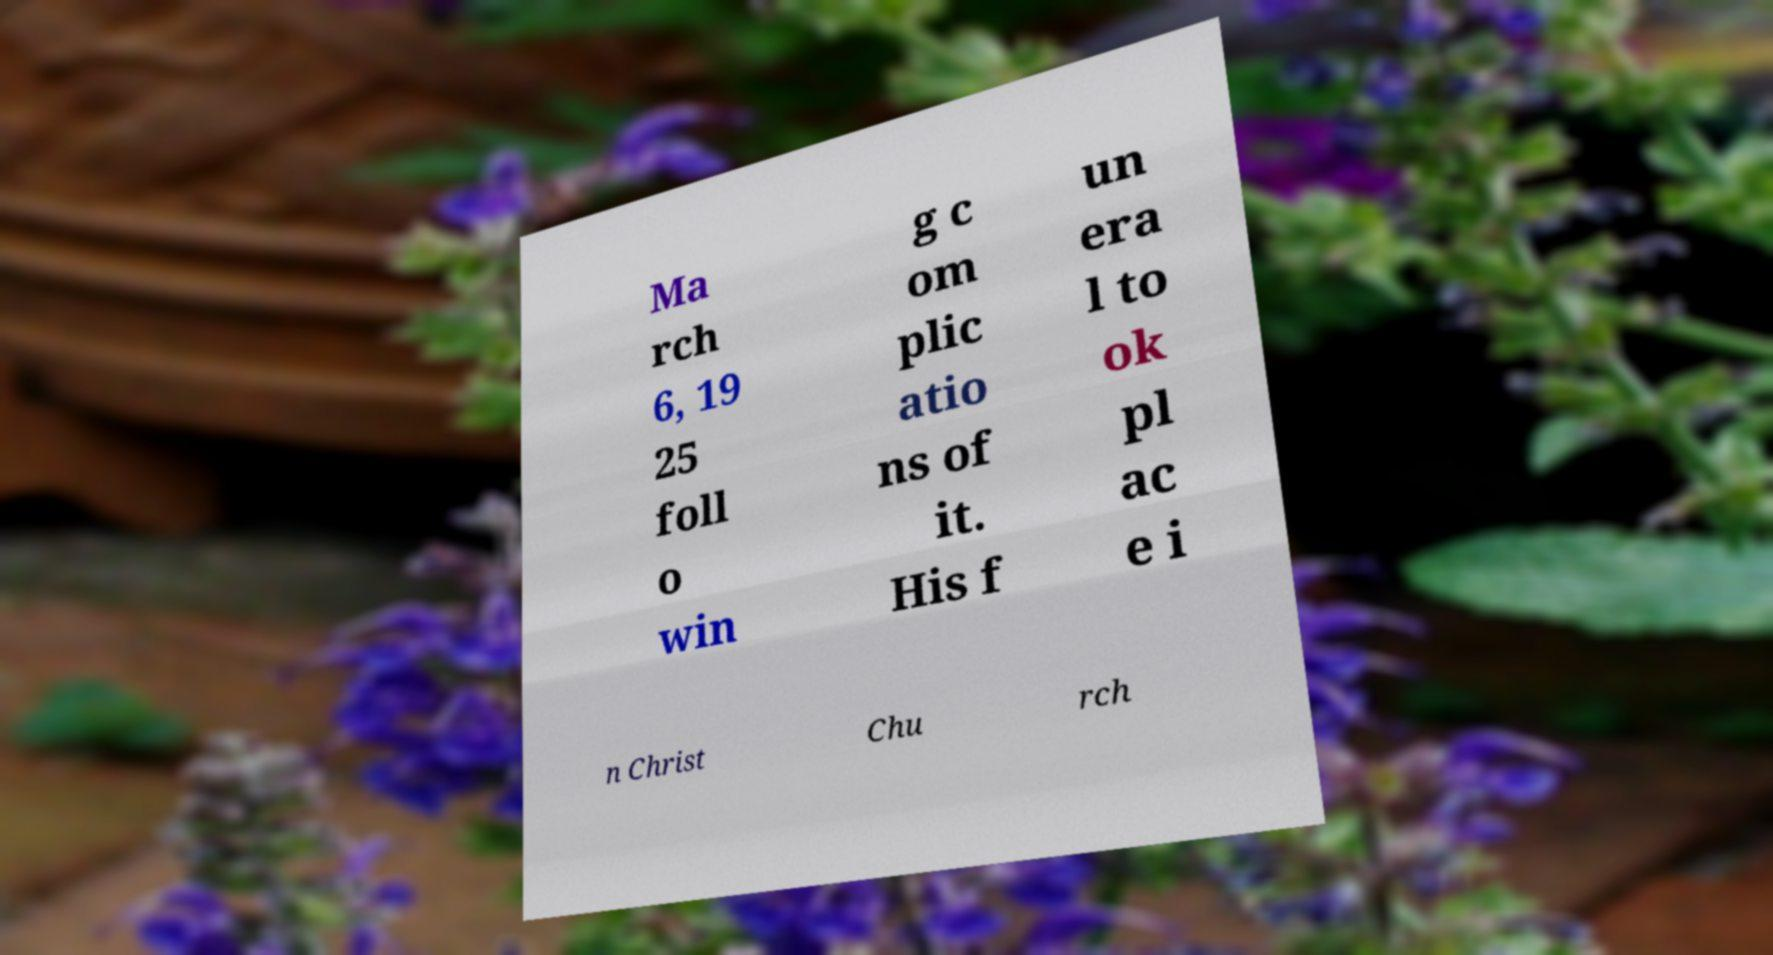Please read and relay the text visible in this image. What does it say? Ma rch 6, 19 25 foll o win g c om plic atio ns of it. His f un era l to ok pl ac e i n Christ Chu rch 